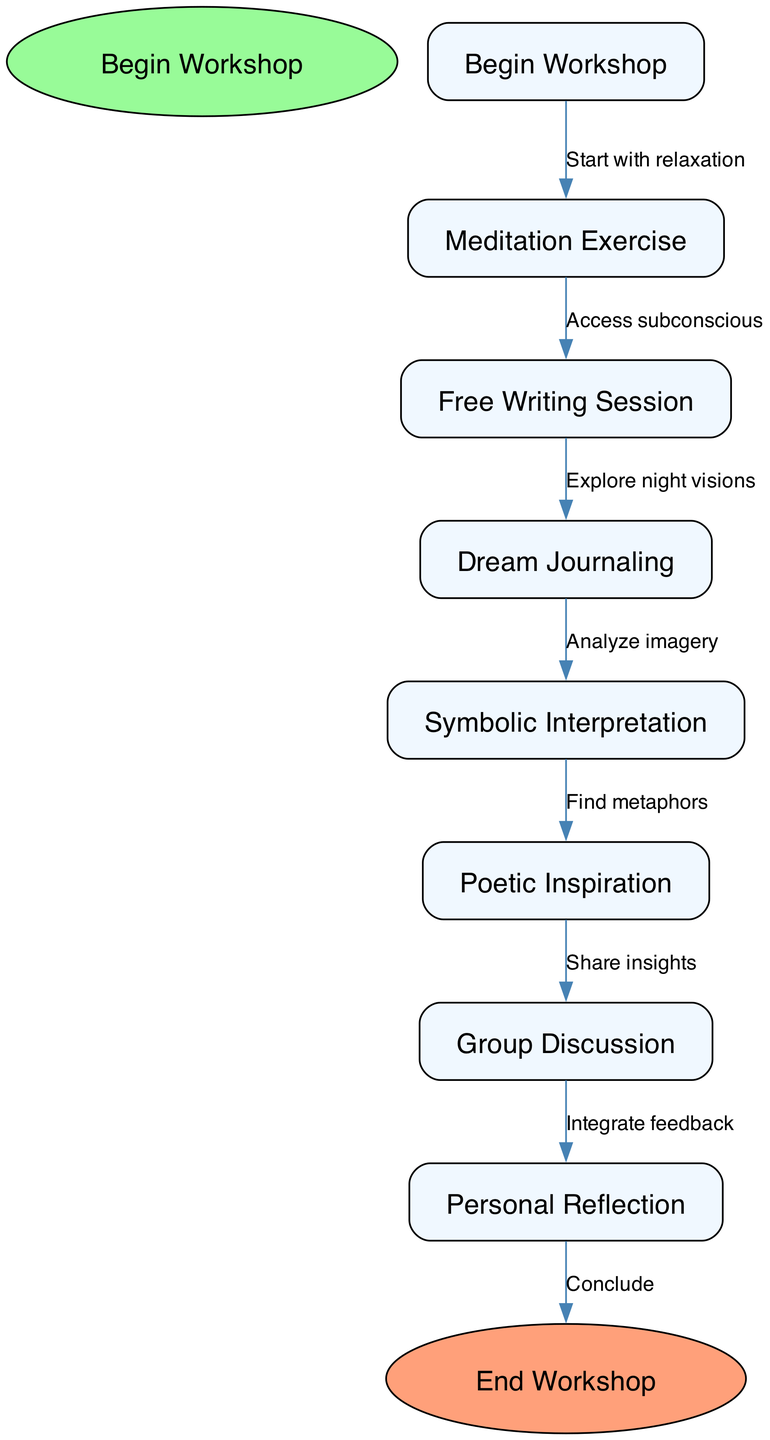What is the starting node of the workshop? The starting node of the workshop is indicated as 'Begin Workshop' at the top of the flowchart.
Answer: Begin Workshop How many nodes are present in the diagram? By counting the nodes listed, there are a total of 7 intermediate nodes in addition to the start and end nodes. Therefore, 7 + 2 = 9 nodes in total.
Answer: 9 What is the first activity after the workshop begins? The first activity after 'Begin Workshop' is shown to be 'Meditation Exercise', which is directly connected from the starting point.
Answer: Meditation Exercise Which activity follows 'Free Writing Session'? The diagram shows that 'Dream Journaling' follows 'Free Writing Session' as the next step in the sequence.
Answer: Dream Journaling What connects 'Dream Journaling' to 'Symbolic Interpretation'? The edge connecting 'Dream Journaling' to 'Symbolic Interpretation' is labeled with 'Analyze imagery', indicating the relationship between these two nodes.
Answer: Analyze imagery Which phase occurs after 'Poetic Inspiration'? After 'Poetic Inspiration', the next phase is 'Group Discussion', as indicated by the directed edge from 'Poetic Inspiration' to 'Group Discussion'.
Answer: Group Discussion What is the last step of the workshop? The last step of the workshop in the flowchart is indicated as 'End Workshop', which is the endpoint after all the previous activities have been completed.
Answer: End Workshop What is the main purpose of the 'Meditation Exercise'? The main purpose of the 'Meditation Exercise' is to 'Start with relaxation', which is essential for preparing participants for the subsequent activities.
Answer: Start with relaxation What does 'Group Discussion' lead into? 'Group Discussion' leads into 'Personal Reflection', indicating that participants will take time to reflect individually after discussing the group insights.
Answer: Personal Reflection 